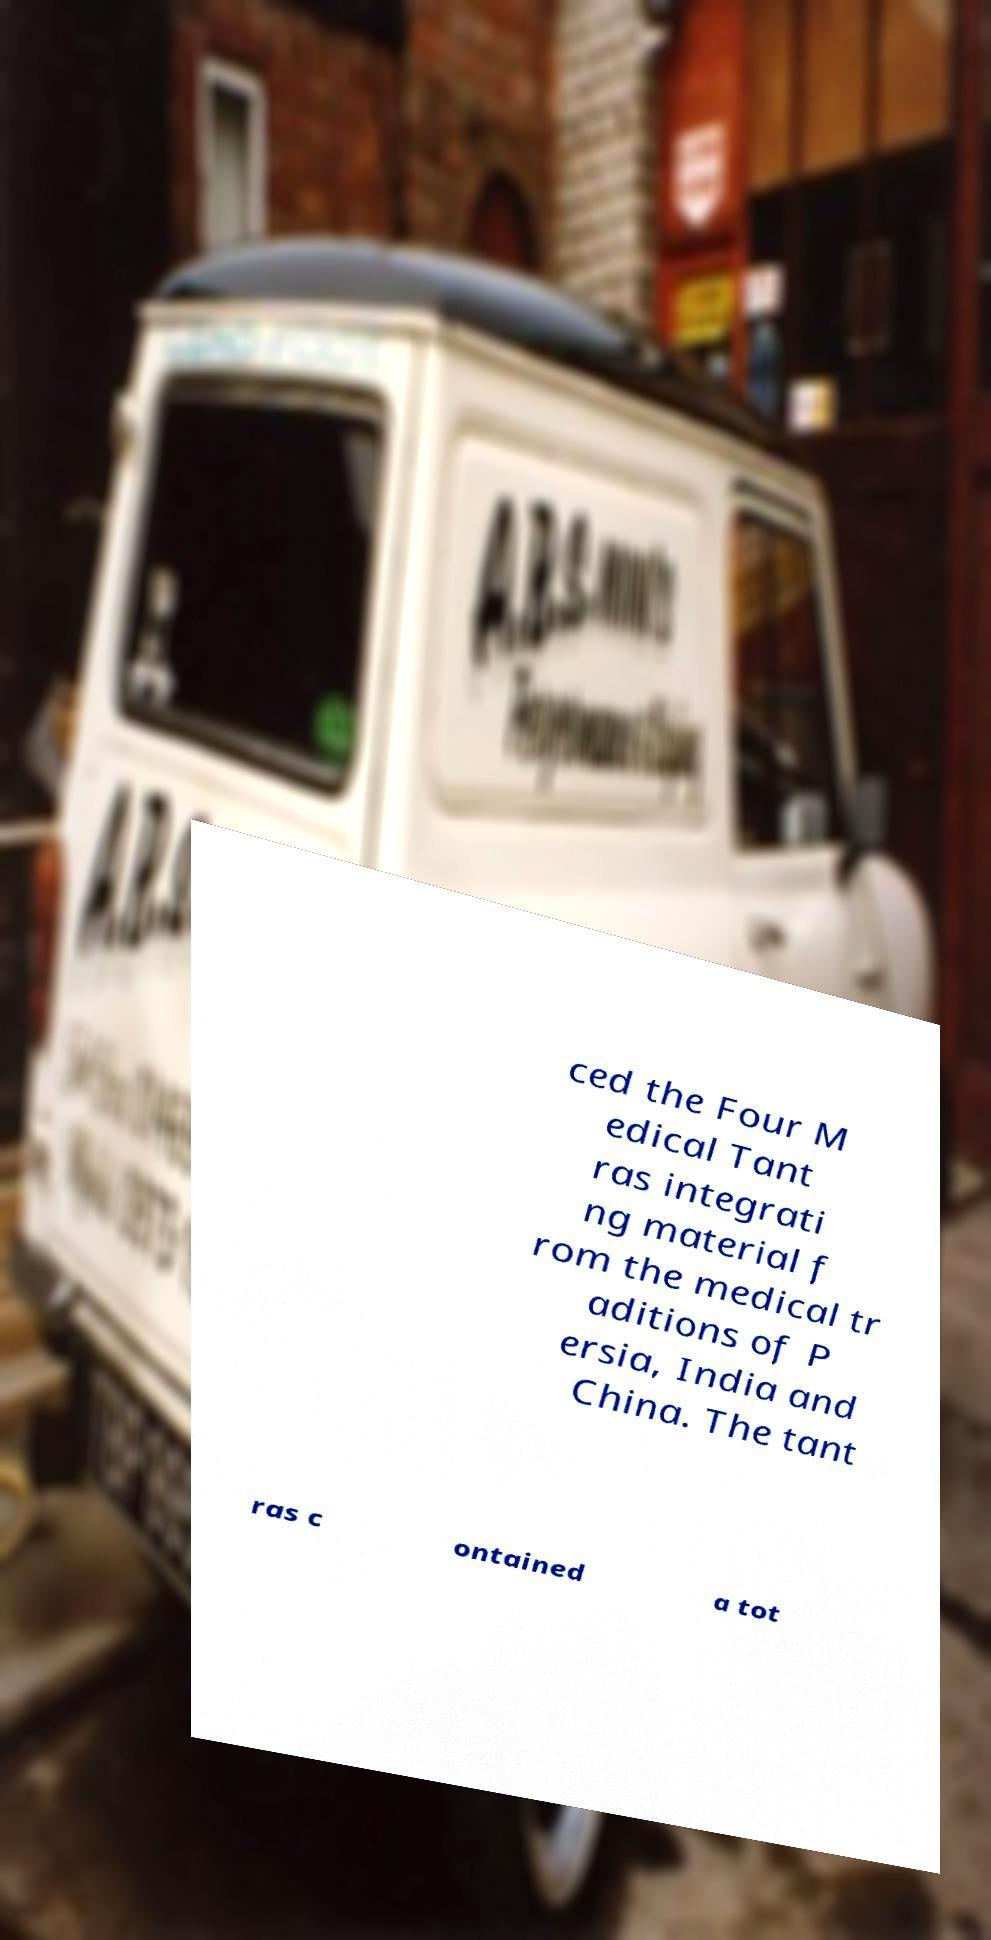Please identify and transcribe the text found in this image. ced the Four M edical Tant ras integrati ng material f rom the medical tr aditions of P ersia, India and China. The tant ras c ontained a tot 